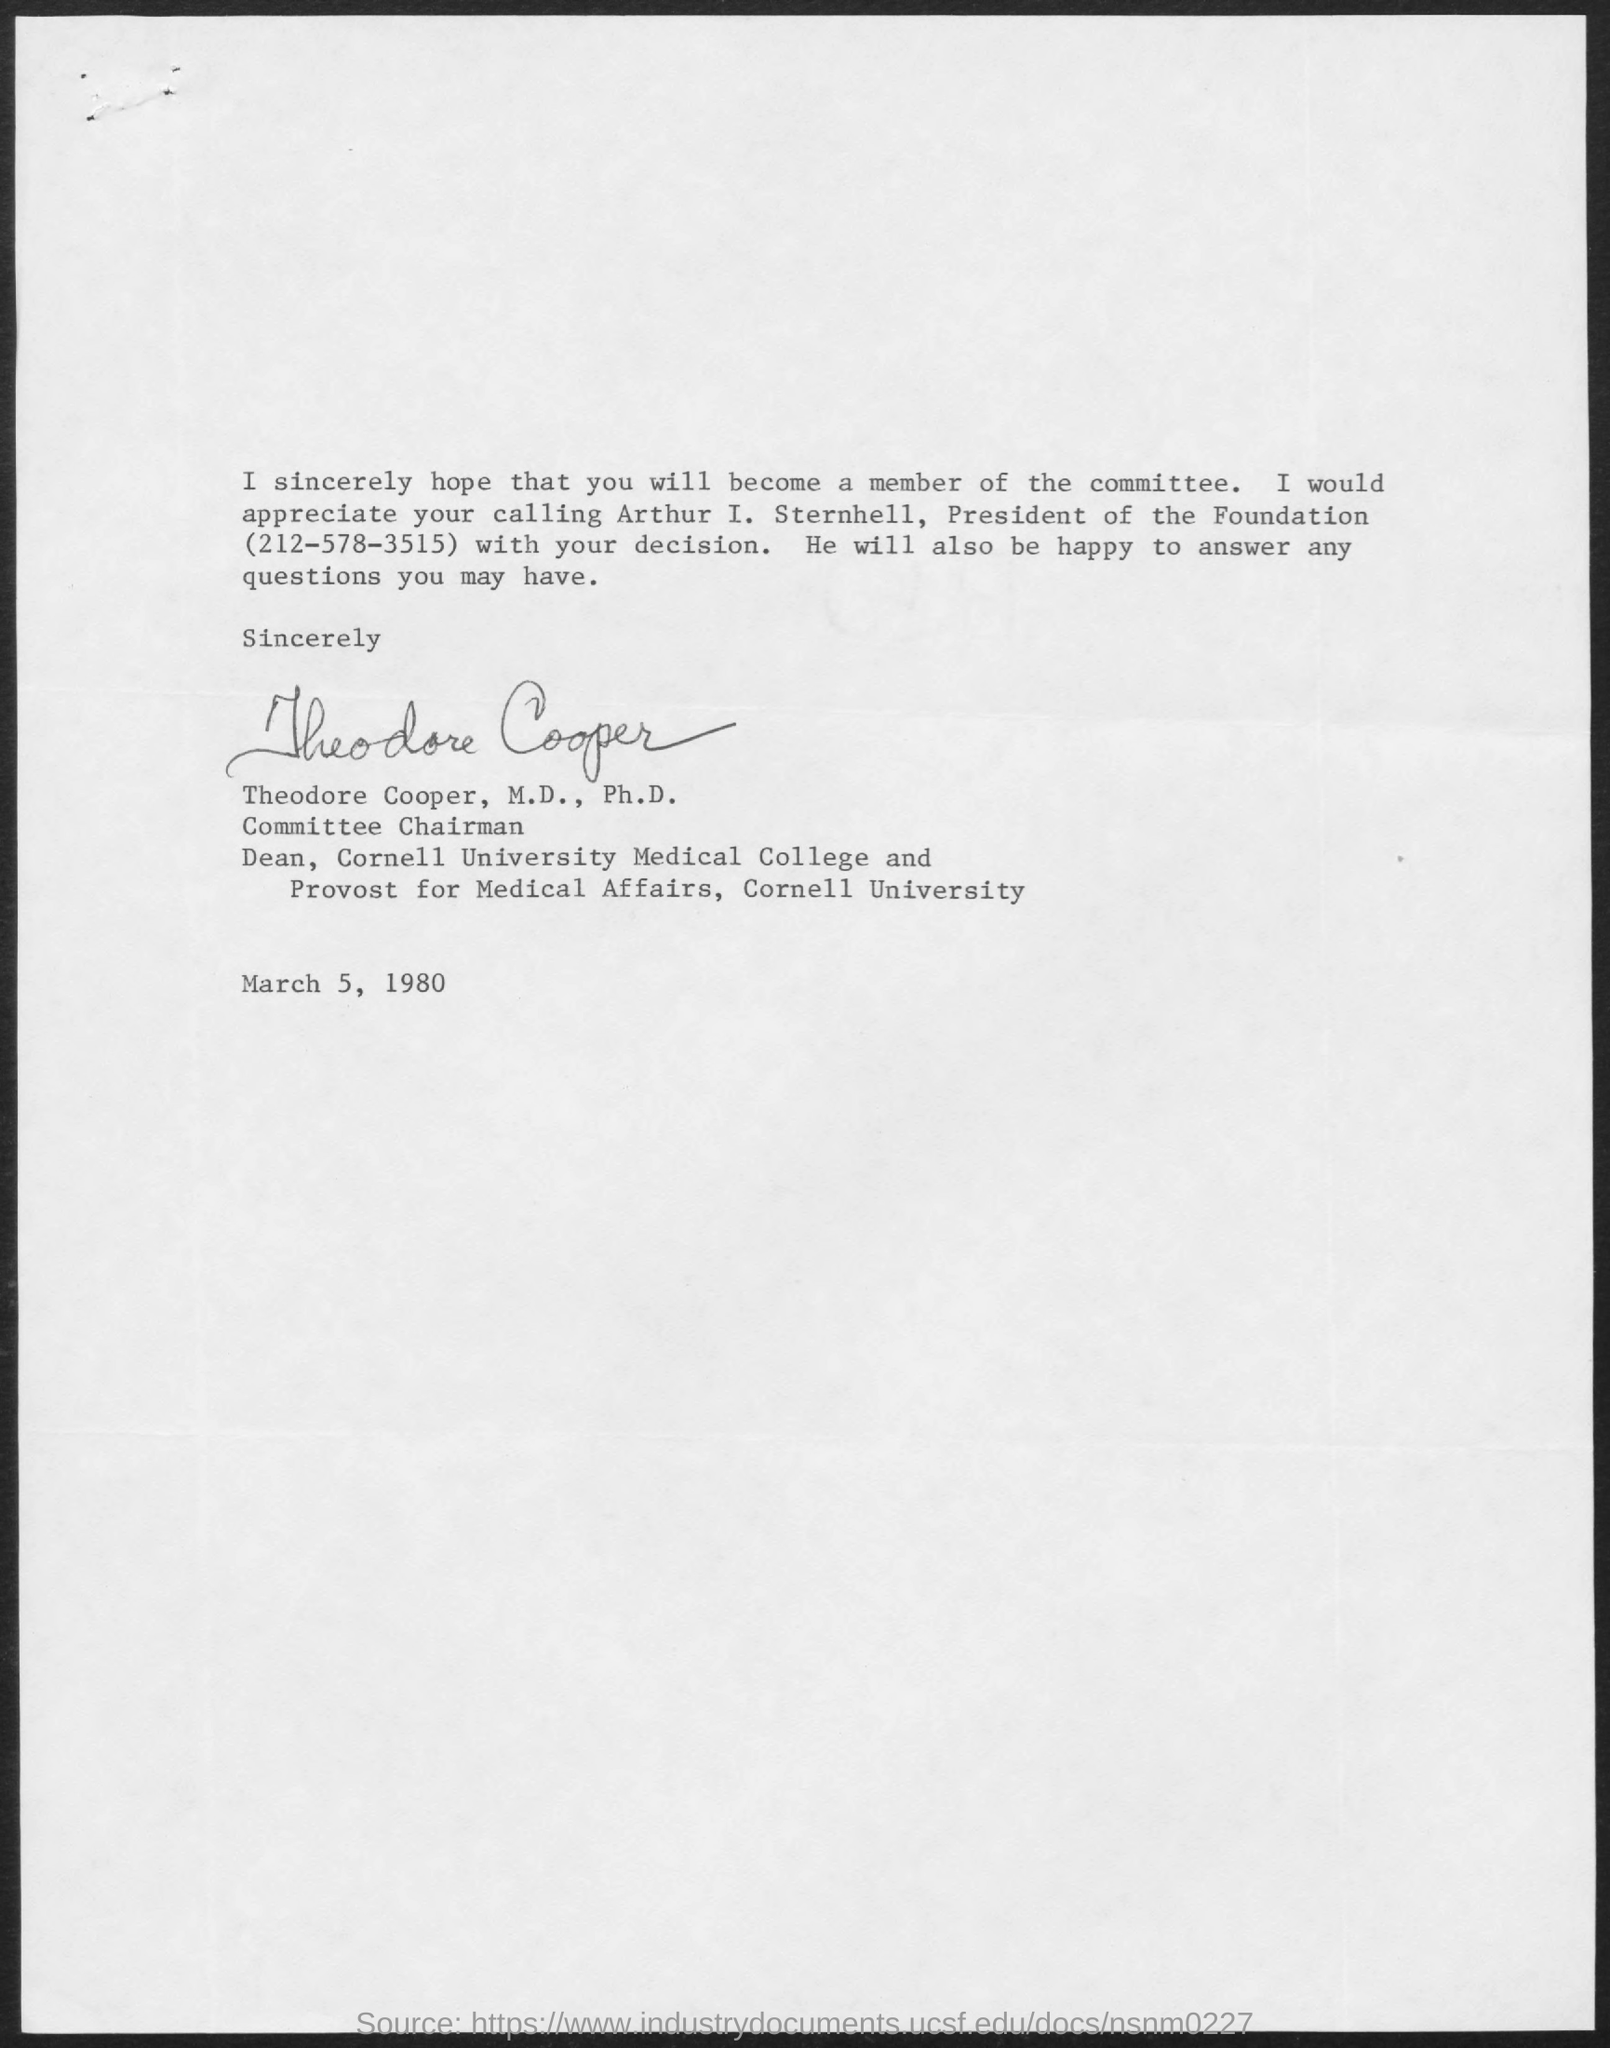Specify some key components in this picture. The letter is from Theodore Cooper. It is known that the President of the foundation is Arthur I. Sternhell. The date on the document is March 5, 1980. 